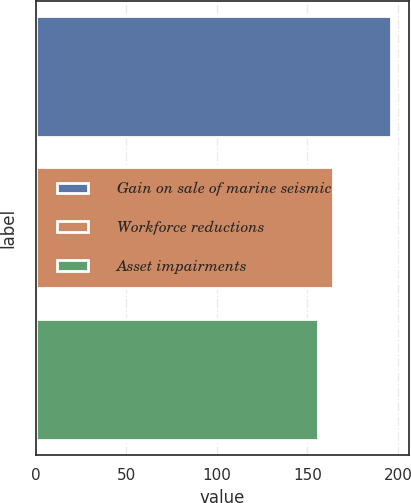<chart> <loc_0><loc_0><loc_500><loc_500><bar_chart><fcel>Gain on sale of marine seismic<fcel>Workforce reductions<fcel>Asset impairments<nl><fcel>196<fcel>164<fcel>156<nl></chart> 